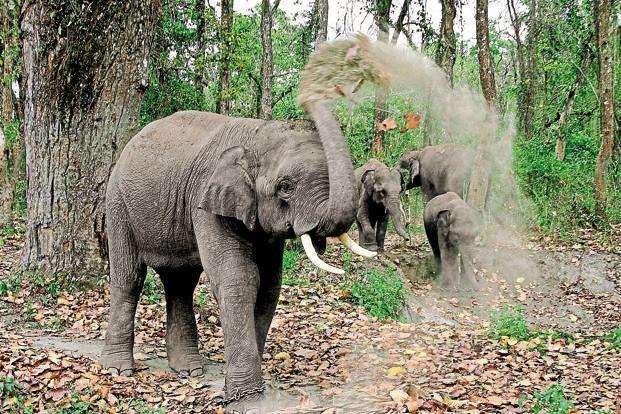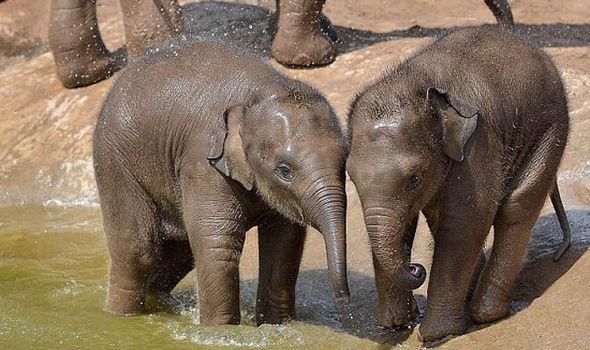The first image is the image on the left, the second image is the image on the right. Analyze the images presented: Is the assertion "There are two elephants fully visible in the picture on the right" valid? Answer yes or no. Yes. The first image is the image on the left, the second image is the image on the right. For the images shown, is this caption "Both images contain an elephant with tusks." true? Answer yes or no. No. 